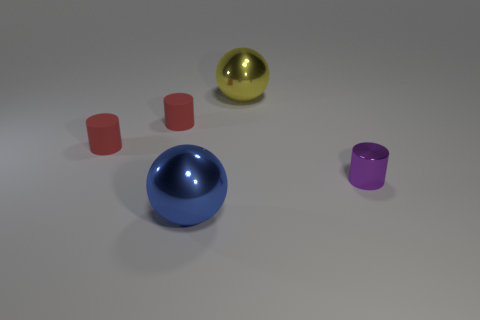The cylinder that is made of the same material as the yellow thing is what color?
Give a very brief answer. Purple. What is the shape of the blue shiny thing that is the same size as the yellow sphere?
Provide a short and direct response. Sphere. Is the number of yellow metal balls in front of the purple object less than the number of tiny red rubber objects that are left of the large yellow object?
Your answer should be compact. Yes. What is the shape of the purple object?
Provide a short and direct response. Cylinder. Are there more small purple shiny cylinders on the right side of the large blue ball than large metal objects that are to the right of the yellow shiny ball?
Your answer should be compact. Yes. Does the large metal object that is to the right of the blue sphere have the same shape as the large metallic thing in front of the small metallic object?
Ensure brevity in your answer.  Yes. How many other objects are the same size as the purple metallic thing?
Give a very brief answer. 2. The yellow metal sphere has what size?
Your answer should be very brief. Large. What is the color of the other metallic object that is the same shape as the big blue shiny thing?
Make the answer very short. Yellow. There is a small purple shiny thing; are there any purple cylinders left of it?
Offer a very short reply. No. 